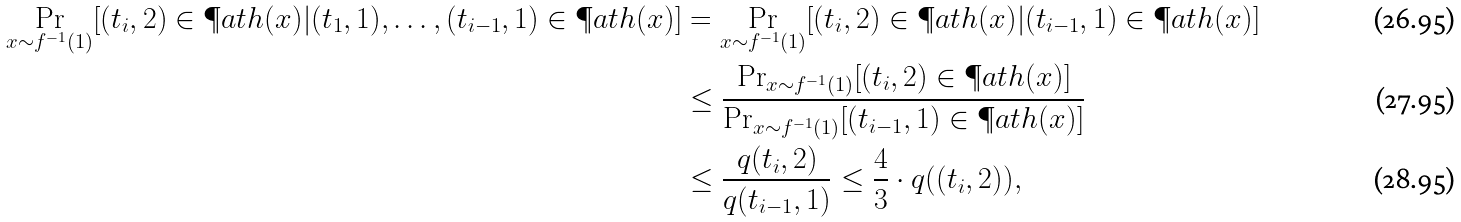Convert formula to latex. <formula><loc_0><loc_0><loc_500><loc_500>\Pr _ { x \sim f ^ { - 1 } ( 1 ) } [ ( t _ { i } , 2 ) \in \P a t h ( x ) | ( t _ { 1 } , 1 ) , \dots , ( t _ { i - 1 } , 1 ) \in \P a t h ( x ) ] & = \Pr _ { x \sim f ^ { - 1 } ( 1 ) } [ ( t _ { i } , 2 ) \in \P a t h ( x ) | ( t _ { i - 1 } , 1 ) \in \P a t h ( x ) ] \\ & \leq \frac { \Pr _ { x \sim f ^ { - 1 } ( 1 ) } [ ( t _ { i } , 2 ) \in \P a t h ( x ) ] } { \Pr _ { x \sim f ^ { - 1 } ( 1 ) } [ ( t _ { i - 1 } , 1 ) \in \P a t h ( x ) ] } \\ & \leq \frac { q ( t _ { i } , 2 ) } { q ( t _ { i - 1 } , 1 ) } \leq \frac { 4 } { 3 } \cdot q ( ( t _ { i } , 2 ) ) ,</formula> 